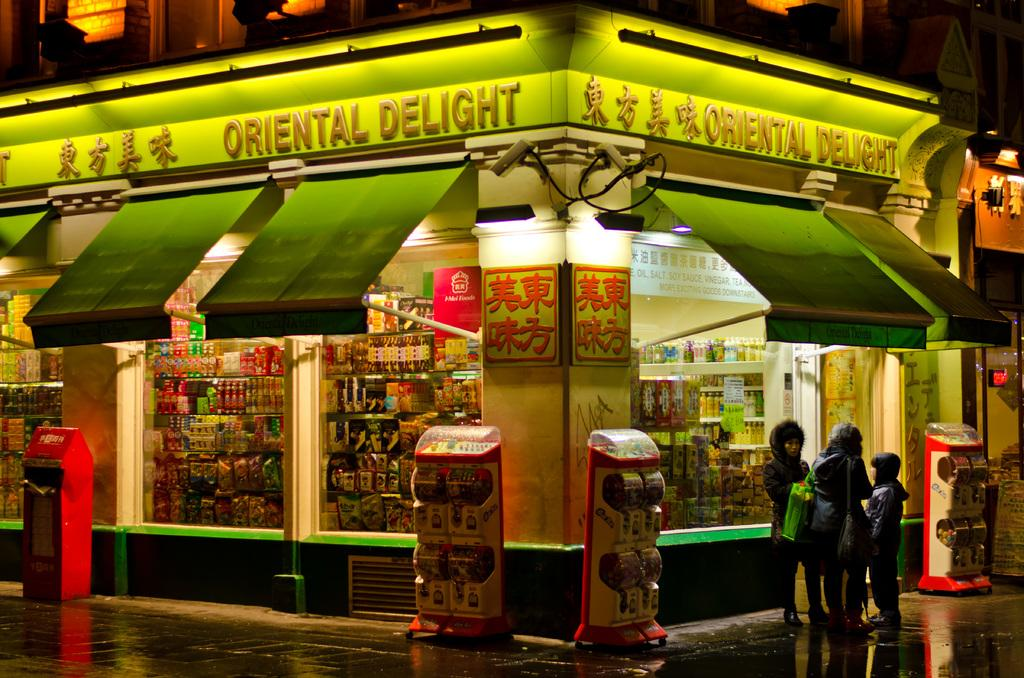<image>
Present a compact description of the photo's key features. The exterior of a restaurant, called Oriental Delight, has green awnings. 